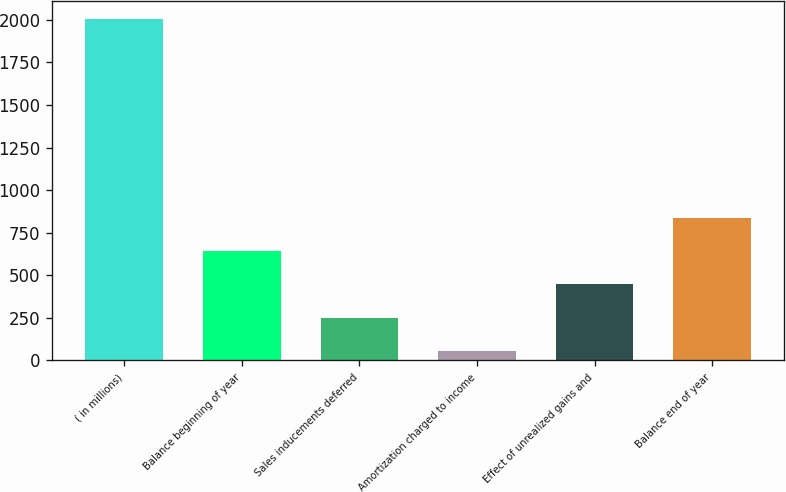Convert chart. <chart><loc_0><loc_0><loc_500><loc_500><bar_chart><fcel>( in millions)<fcel>Balance beginning of year<fcel>Sales inducements deferred<fcel>Amortization charged to income<fcel>Effect of unrealized gains and<fcel>Balance end of year<nl><fcel>2007<fcel>642<fcel>252<fcel>57<fcel>447<fcel>837<nl></chart> 